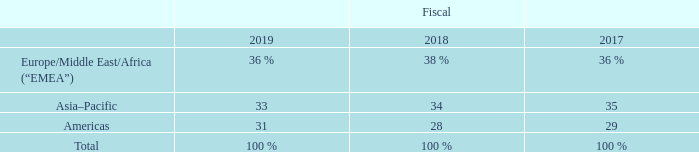Sales and Distribution
We maintain a strong local presence in each of the geographic regions in which we operate. Our net sales by geographic region(1) as a percentage of our total net sales were as follows:
(1) Net sales to external customers are attributed to individual countries based on the legal entity that records the sale.
We sell our products into approximately 150 countries primarily through direct selling efforts to manufacturers. In fiscal 2019, our direct sales represented approximately 80% of total net sales. We also sell our products indirectly via third-party distributors.
We maintain distribution centers around the world. Products are generally delivered to the distribution centers by our manufacturing facilities and then subsequently delivered to the customer. In some instances, however, products are delivered directly from our manufacturing facility to the customer. Our global coverage positions us near our customers’ locations and allows us to assist them in consolidating their supply base and lowering their production costs. We contract with a wide range of transport providers to deliver our products globally via road, rail, sea, and air. We believe our balanced sales distribution lowers our exposure to any particular geography and improves our financial profile.
What are the net sales by geographic region to external customers attributed to? Individual countries based on the legal entity that records the sale. What are the net sales by geographic region in the table presented as a percentage of? Total net sales. Which are the geographic regions in which the company operates in? Europe/middle east/africa (“emea”), asia–pacific, americas. In which year was the percentage in Americas the largest? 31%>29%>28%
Answer: 2019. What was the change in percentage in Americas in 2019 from 2018?
Answer scale should be: percent. 31-28
Answer: 3. What was the average net sales in Asia-Pacific as a percentage of total net sales across 2017, 2018 and 2019?
Answer scale should be: percent. (33+34+35)/3
Answer: 34. 